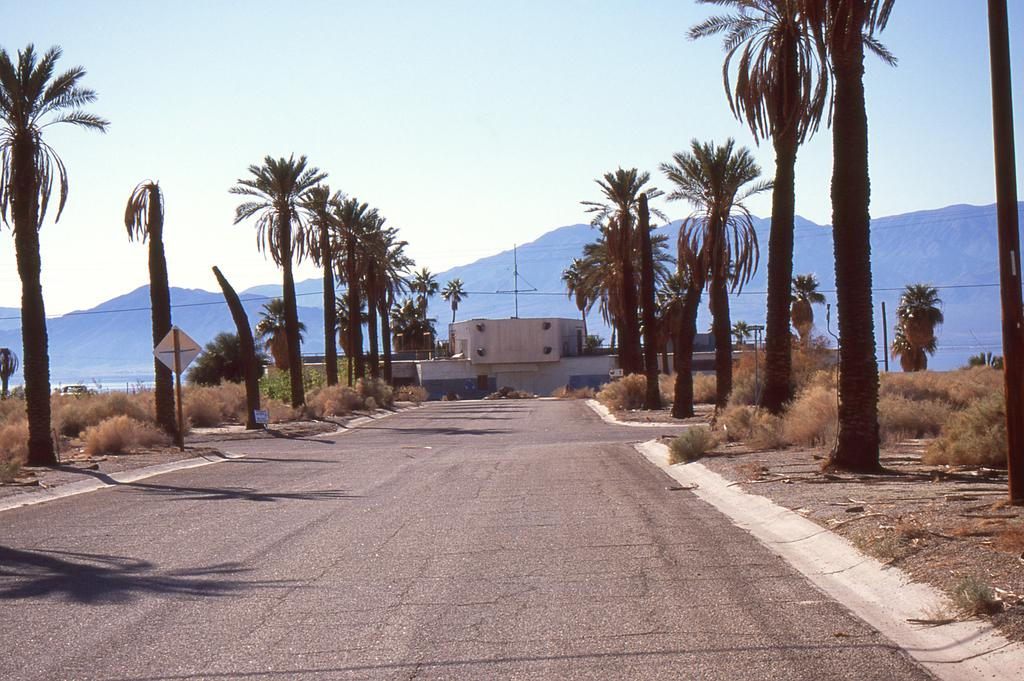What is the main feature of the image? There is a road in the image. What can be seen on the left side of the road? There are trees on the left side of the road. What can be seen on the right side of the road? There are plants on the right side of the road. What structures are in front of the road? There is a house and poles in front of the road. What natural feature is visible in front of the road? There are hills in front of the road. What part of the sky is visible in the image? The sky is visible in the image. How many beds can be seen in the image? There are no beds present in the image. What type of riddle is depicted in the image? There is no riddle depicted in the image. 